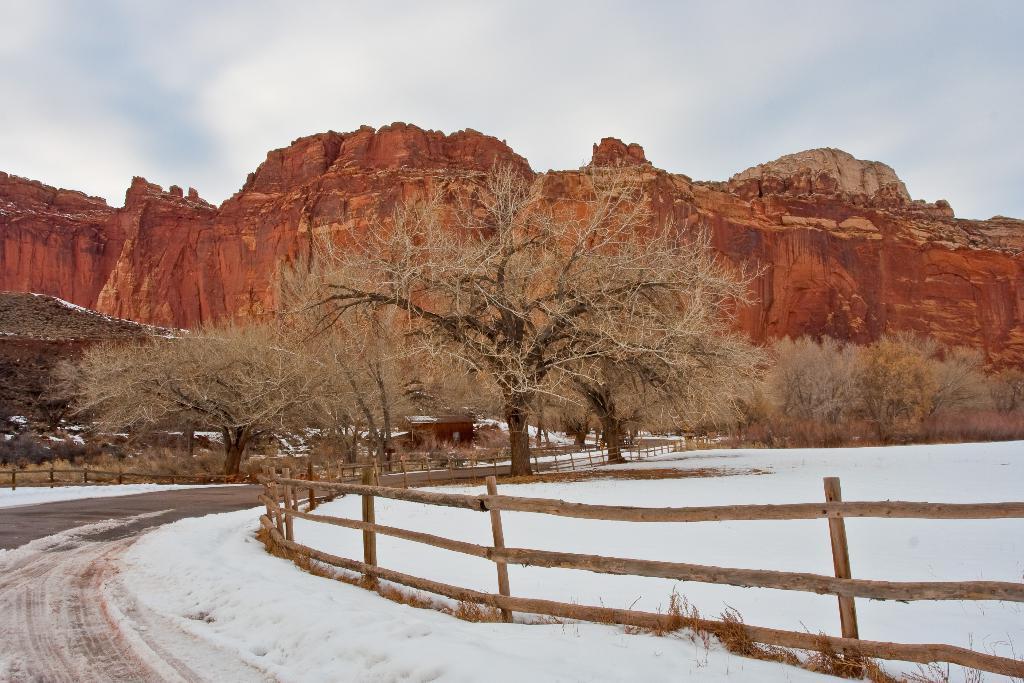Can you describe this image briefly? In this picture, we can see the ground with snow, and we can see path, fencing, houses, trees, mountains, and the sky with clouds. 